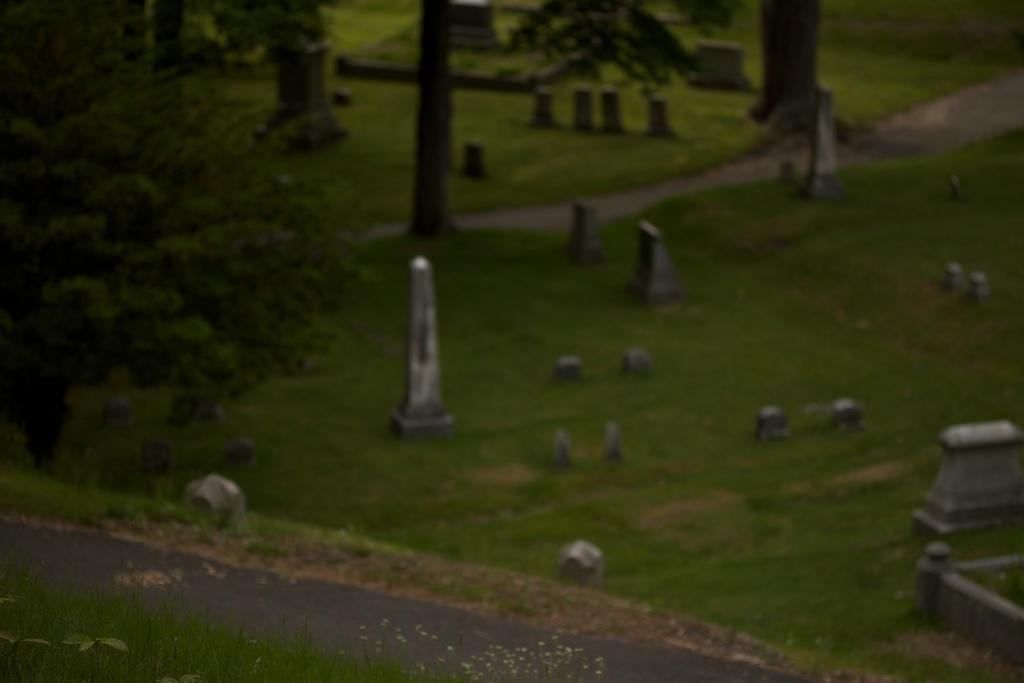What is located in the center of the image? There are stones in the center of the image. What type of vegetation is present on the ground in the image? There is grass on the ground in the image. What can be seen on the left side of the image? There is a tree on the left side of the image. What is visible in the background of the image? There are trees and stones in the background of the image. Can you tell me how many nuts are on the tree in the image? There are no nuts mentioned or visible in the image; it features stones, grass, and trees. What color is the sister's nose in the image? There is no person, let alone a sister, present in the image. 